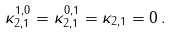Convert formula to latex. <formula><loc_0><loc_0><loc_500><loc_500>\kappa _ { 2 , 1 } ^ { 1 , 0 } = \kappa _ { 2 , 1 } ^ { 0 , 1 } = \kappa _ { 2 , 1 } = 0 \, .</formula> 